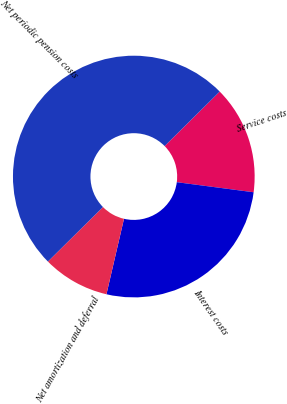Convert chart to OTSL. <chart><loc_0><loc_0><loc_500><loc_500><pie_chart><fcel>Service costs<fcel>Interest costs<fcel>Net amortization and deferral<fcel>Net periodic pension costs<nl><fcel>14.49%<fcel>26.56%<fcel>8.95%<fcel>50.0%<nl></chart> 